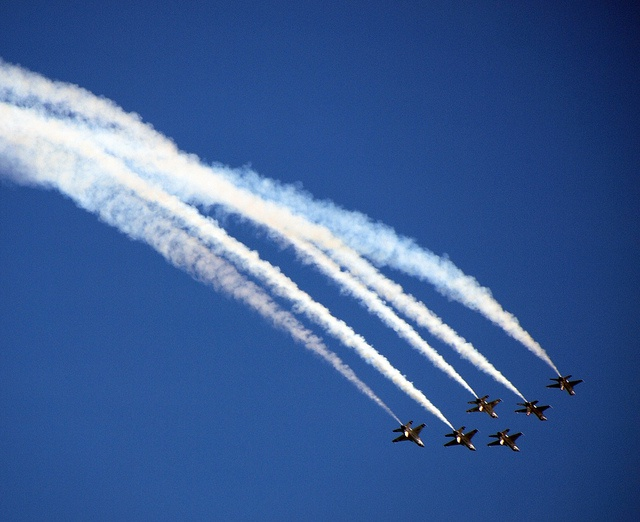Describe the objects in this image and their specific colors. I can see airplane in darkblue, black, navy, blue, and maroon tones, airplane in darkblue, black, gray, navy, and maroon tones, airplane in darkblue, black, navy, blue, and maroon tones, airplane in darkblue, black, maroon, navy, and gray tones, and airplane in darkblue, black, navy, and maroon tones in this image. 